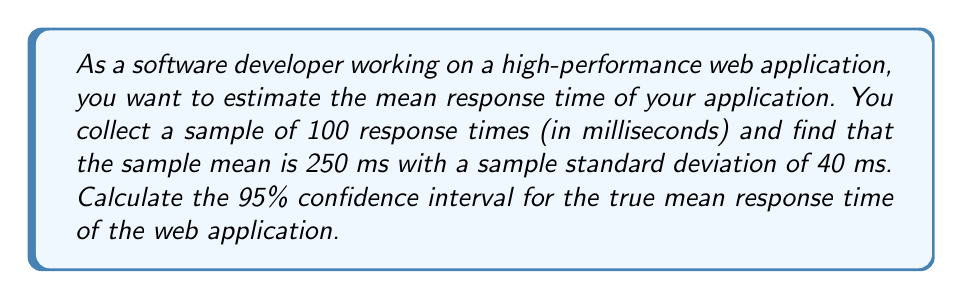Help me with this question. To calculate the confidence interval for the mean response time, we'll use the formula:

$$ \text{CI} = \bar{x} \pm t_{\alpha/2, n-1} \cdot \frac{s}{\sqrt{n}} $$

Where:
- $\bar{x}$ is the sample mean
- $t_{\alpha/2, n-1}$ is the t-value for a 95% confidence level with n-1 degrees of freedom
- $s$ is the sample standard deviation
- $n$ is the sample size

Given:
- Sample mean $\bar{x} = 250$ ms
- Sample standard deviation $s = 40$ ms
- Sample size $n = 100$
- Confidence level = 95%

Steps:
1. Find the t-value:
   With 95% confidence level and 99 degrees of freedom (n-1 = 99), the t-value is approximately 1.984 (from t-distribution table or calculator).

2. Calculate the margin of error:
   $$ \text{Margin of Error} = t_{\alpha/2, n-1} \cdot \frac{s}{\sqrt{n}} = 1.984 \cdot \frac{40}{\sqrt{100}} = 1.984 \cdot 4 = 7.936 $$

3. Calculate the confidence interval:
   $$ \text{CI} = 250 \pm 7.936 $$
   $$ \text{CI} = (242.064, 257.936) $$
Answer: The 95% confidence interval for the true mean response time of the web application is (242.064 ms, 257.936 ms). 